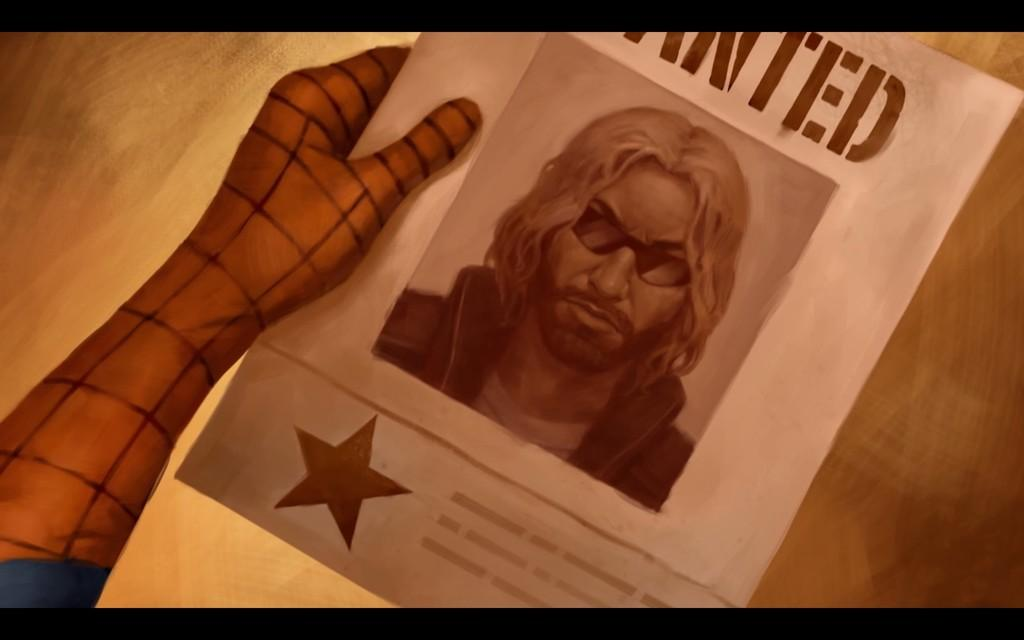Provide a one-sentence caption for the provided image. Poster showing a man wearing sunglasses that is wanted. 